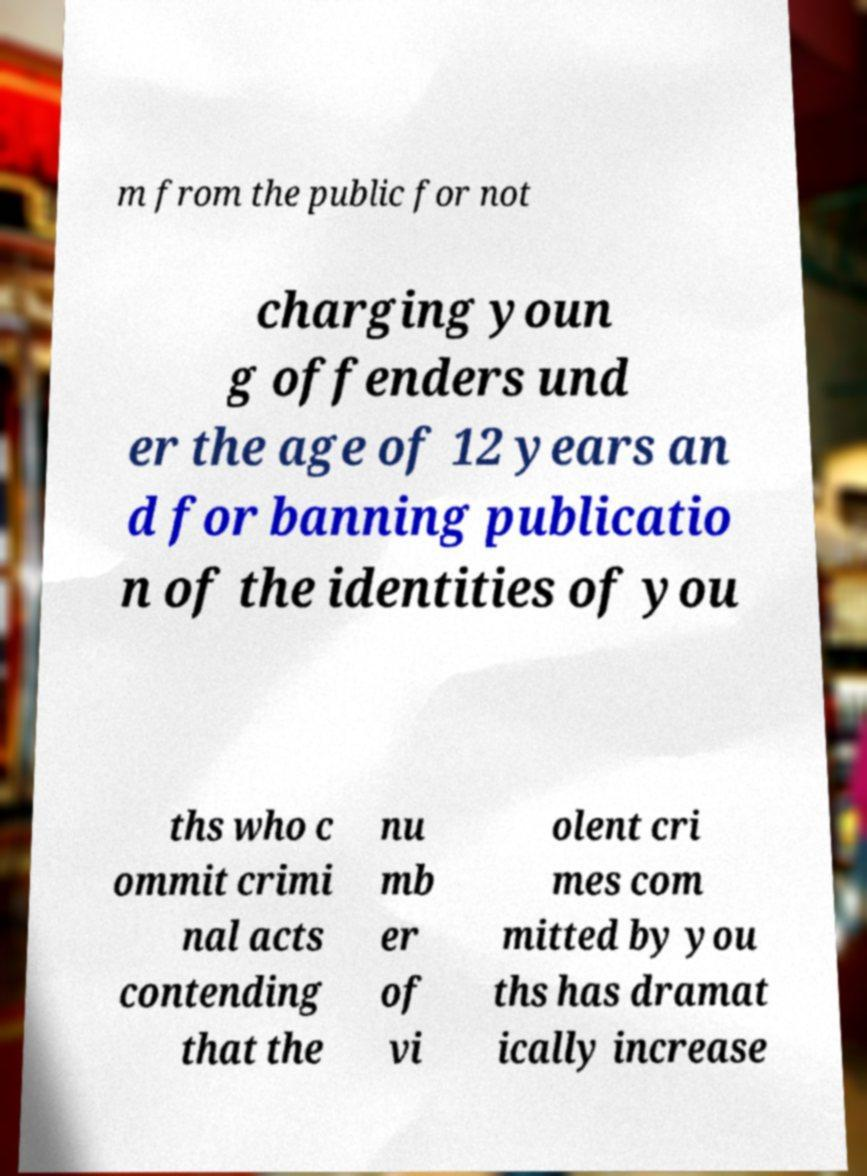Can you accurately transcribe the text from the provided image for me? m from the public for not charging youn g offenders und er the age of 12 years an d for banning publicatio n of the identities of you ths who c ommit crimi nal acts contending that the nu mb er of vi olent cri mes com mitted by you ths has dramat ically increase 